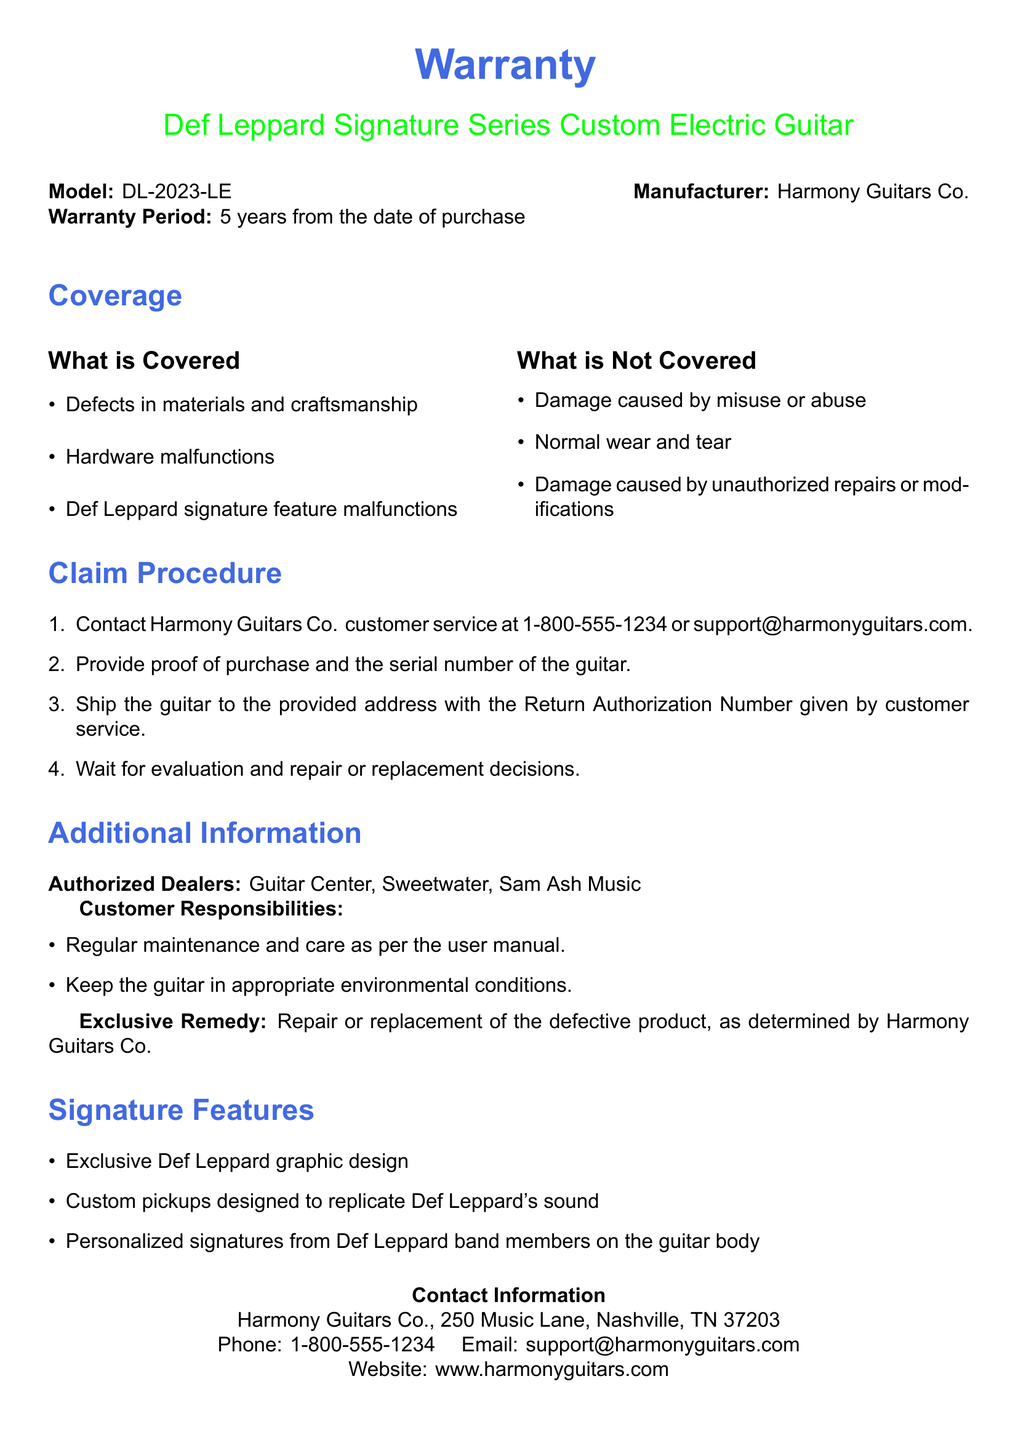What is the warranty period for the guitar? The warranty period is stated in the document as 5 years from the date of purchase.
Answer: 5 years What is covered under the warranty? The document lists specific items such as defects in materials and craftsmanship as covered items.
Answer: Defects in materials and craftsmanship What should you provide when making a claim? The claim procedure specifies that proof of purchase and the serial number of the guitar must be provided.
Answer: Proof of purchase and the serial number Who is the manufacturer of the guitar? The manufacturer is clearly mentioned in the document as Harmony Guitars Co.
Answer: Harmony Guitars Co What is not covered by the warranty? The document outlines that damage caused by misuse or abuse is not covered.
Answer: Damage caused by misuse or abuse What is the exclusive remedy offered by Harmony Guitars Co.? The document indicates that the exclusive remedy is the repair or replacement of the defective product.
Answer: Repair or replacement Where can customers contact for support? The contact information section in the document provides a phone number for customer support.
Answer: 1-800-555-1234 What additional features does this guitar have? The signature features list details what additional features are present in the guitar.
Answer: Exclusive Def Leppard graphic design What should customers maintain for the guitar? The customer responsibilities section outlines that regular maintenance and care must be adhered to.
Answer: Regular maintenance and care 